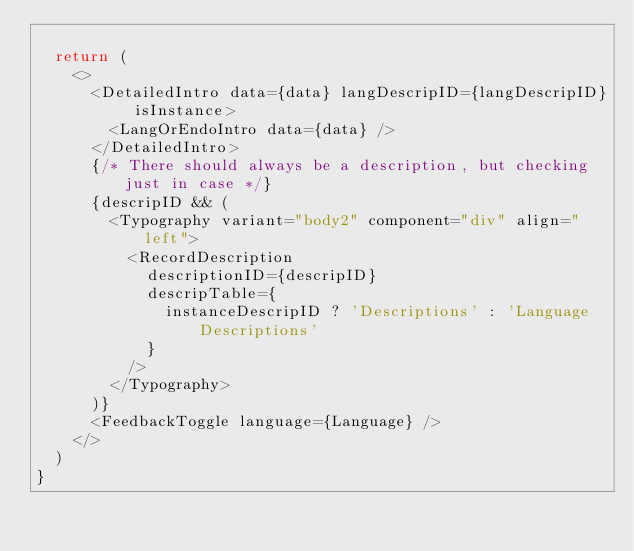<code> <loc_0><loc_0><loc_500><loc_500><_TypeScript_>
  return (
    <>
      <DetailedIntro data={data} langDescripID={langDescripID} isInstance>
        <LangOrEndoIntro data={data} />
      </DetailedIntro>
      {/* There should always be a description, but checking just in case */}
      {descripID && (
        <Typography variant="body2" component="div" align="left">
          <RecordDescription
            descriptionID={descripID}
            descripTable={
              instanceDescripID ? 'Descriptions' : 'Language Descriptions'
            }
          />
        </Typography>
      )}
      <FeedbackToggle language={Language} />
    </>
  )
}
</code> 